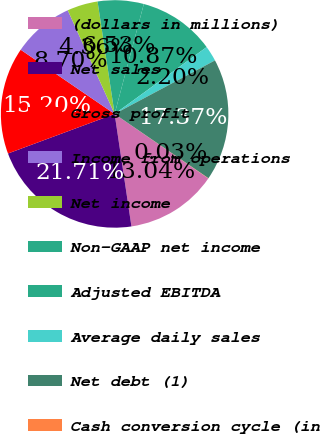Convert chart to OTSL. <chart><loc_0><loc_0><loc_500><loc_500><pie_chart><fcel>(dollars in millions)<fcel>Net sales<fcel>Gross profit<fcel>Income from operations<fcel>Net income<fcel>Non-GAAP net income<fcel>Adjusted EBITDA<fcel>Average daily sales<fcel>Net debt (1)<fcel>Cash conversion cycle (in<nl><fcel>13.04%<fcel>21.71%<fcel>15.2%<fcel>8.7%<fcel>4.36%<fcel>6.53%<fcel>10.87%<fcel>2.2%<fcel>17.37%<fcel>0.03%<nl></chart> 